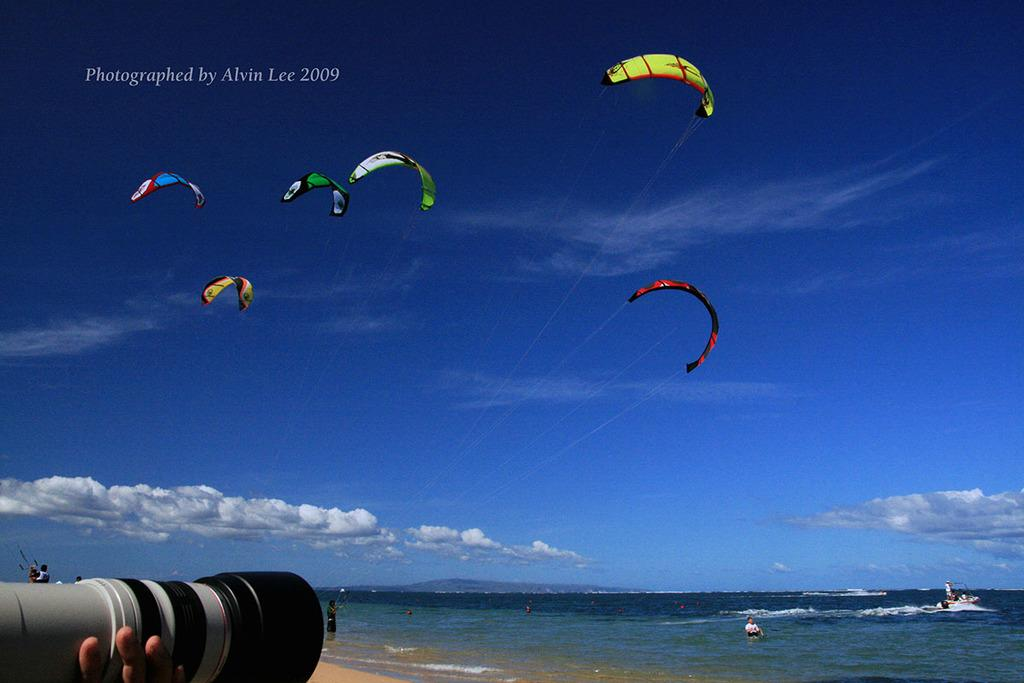What activity are the persons in the center of the image engaged in? The persons in the center of the image are kitesurfing. How would you describe the weather based on the image? The sky is cloudy in the image. Can you identify any equipment used for capturing images in the image? Yes, there is a camera visible in the image. Who is holding the camera in the image? A person is holding the camera in the image. How many snakes are slithering around the kitesurfers in the image? There are no snakes present in the image; the persons are kitesurfing in the water. Can you hear the persons kitesurfing laughing in the image? The image is a still photograph and does not capture sound, so we cannot hear any laughter. 